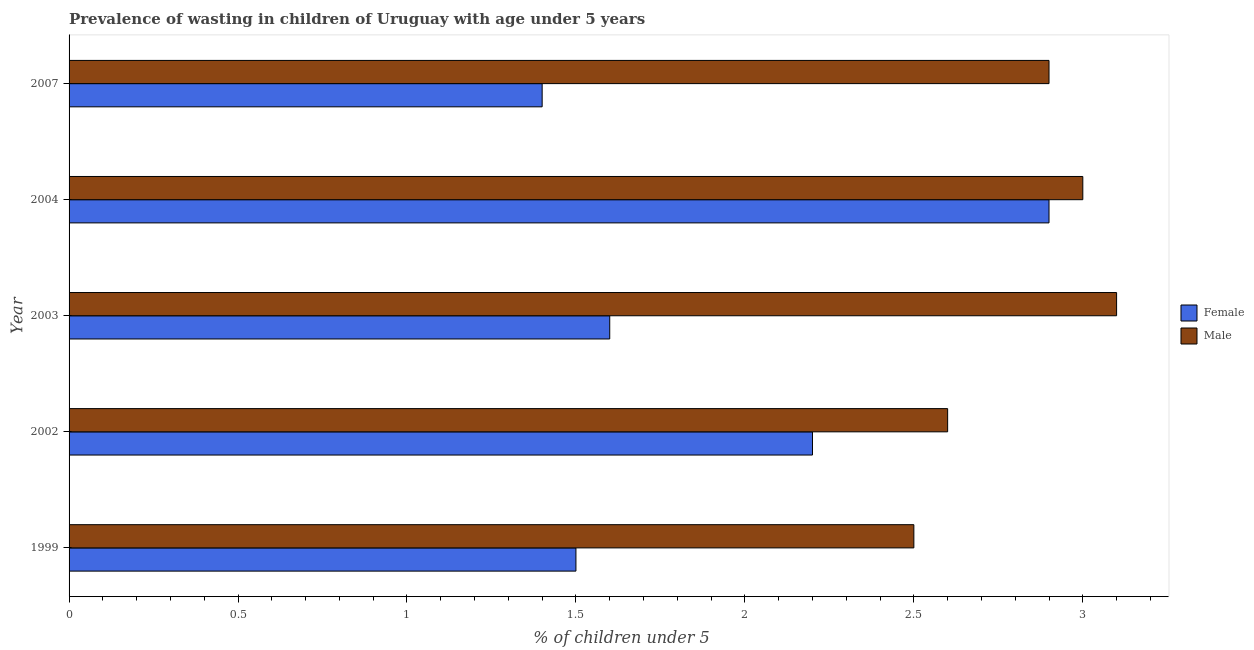How many different coloured bars are there?
Make the answer very short. 2. Are the number of bars per tick equal to the number of legend labels?
Keep it short and to the point. Yes. Are the number of bars on each tick of the Y-axis equal?
Make the answer very short. Yes. In how many cases, is the number of bars for a given year not equal to the number of legend labels?
Provide a short and direct response. 0. Across all years, what is the maximum percentage of undernourished male children?
Offer a terse response. 3.1. Across all years, what is the minimum percentage of undernourished male children?
Your response must be concise. 2.5. In which year was the percentage of undernourished male children maximum?
Provide a short and direct response. 2003. In which year was the percentage of undernourished female children minimum?
Ensure brevity in your answer.  2007. What is the total percentage of undernourished male children in the graph?
Your answer should be very brief. 14.1. What is the difference between the percentage of undernourished male children in 1999 and that in 2004?
Ensure brevity in your answer.  -0.5. What is the difference between the percentage of undernourished female children in 1999 and the percentage of undernourished male children in 2007?
Offer a very short reply. -1.4. What is the average percentage of undernourished male children per year?
Your answer should be compact. 2.82. In the year 2004, what is the difference between the percentage of undernourished female children and percentage of undernourished male children?
Offer a terse response. -0.1. In how many years, is the percentage of undernourished male children greater than 3 %?
Your response must be concise. 1. What is the ratio of the percentage of undernourished female children in 2002 to that in 2004?
Your answer should be very brief. 0.76. Is the percentage of undernourished female children in 2003 less than that in 2004?
Provide a short and direct response. Yes. Is the difference between the percentage of undernourished male children in 2003 and 2004 greater than the difference between the percentage of undernourished female children in 2003 and 2004?
Give a very brief answer. Yes. Are all the bars in the graph horizontal?
Provide a succinct answer. Yes. What is the difference between two consecutive major ticks on the X-axis?
Your answer should be very brief. 0.5. Does the graph contain grids?
Your answer should be compact. No. Where does the legend appear in the graph?
Your answer should be compact. Center right. How many legend labels are there?
Offer a terse response. 2. How are the legend labels stacked?
Your response must be concise. Vertical. What is the title of the graph?
Your answer should be compact. Prevalence of wasting in children of Uruguay with age under 5 years. What is the label or title of the X-axis?
Your answer should be compact.  % of children under 5. What is the label or title of the Y-axis?
Offer a terse response. Year. What is the  % of children under 5 of Female in 1999?
Provide a succinct answer. 1.5. What is the  % of children under 5 of Male in 1999?
Keep it short and to the point. 2.5. What is the  % of children under 5 of Female in 2002?
Your response must be concise. 2.2. What is the  % of children under 5 of Male in 2002?
Offer a very short reply. 2.6. What is the  % of children under 5 in Female in 2003?
Give a very brief answer. 1.6. What is the  % of children under 5 of Male in 2003?
Your answer should be very brief. 3.1. What is the  % of children under 5 in Female in 2004?
Provide a succinct answer. 2.9. What is the  % of children under 5 of Female in 2007?
Offer a terse response. 1.4. What is the  % of children under 5 in Male in 2007?
Provide a succinct answer. 2.9. Across all years, what is the maximum  % of children under 5 of Female?
Offer a very short reply. 2.9. Across all years, what is the maximum  % of children under 5 in Male?
Provide a short and direct response. 3.1. Across all years, what is the minimum  % of children under 5 of Female?
Offer a terse response. 1.4. Across all years, what is the minimum  % of children under 5 in Male?
Offer a very short reply. 2.5. What is the total  % of children under 5 of Female in the graph?
Keep it short and to the point. 9.6. What is the difference between the  % of children under 5 in Female in 1999 and that in 2002?
Offer a very short reply. -0.7. What is the difference between the  % of children under 5 of Female in 1999 and that in 2003?
Provide a succinct answer. -0.1. What is the difference between the  % of children under 5 of Male in 1999 and that in 2003?
Give a very brief answer. -0.6. What is the difference between the  % of children under 5 in Male in 2002 and that in 2004?
Your answer should be very brief. -0.4. What is the difference between the  % of children under 5 of Male in 2002 and that in 2007?
Your response must be concise. -0.3. What is the difference between the  % of children under 5 of Male in 2003 and that in 2004?
Keep it short and to the point. 0.1. What is the difference between the  % of children under 5 of Female in 2004 and that in 2007?
Give a very brief answer. 1.5. What is the difference between the  % of children under 5 of Female in 1999 and the  % of children under 5 of Male in 2003?
Ensure brevity in your answer.  -1.6. What is the difference between the  % of children under 5 in Female in 2002 and the  % of children under 5 in Male in 2003?
Your answer should be compact. -0.9. What is the difference between the  % of children under 5 in Female in 2003 and the  % of children under 5 in Male in 2004?
Keep it short and to the point. -1.4. What is the difference between the  % of children under 5 in Female in 2004 and the  % of children under 5 in Male in 2007?
Ensure brevity in your answer.  0. What is the average  % of children under 5 of Female per year?
Provide a short and direct response. 1.92. What is the average  % of children under 5 of Male per year?
Give a very brief answer. 2.82. In the year 2002, what is the difference between the  % of children under 5 in Female and  % of children under 5 in Male?
Give a very brief answer. -0.4. In the year 2004, what is the difference between the  % of children under 5 in Female and  % of children under 5 in Male?
Give a very brief answer. -0.1. In the year 2007, what is the difference between the  % of children under 5 of Female and  % of children under 5 of Male?
Make the answer very short. -1.5. What is the ratio of the  % of children under 5 of Female in 1999 to that in 2002?
Ensure brevity in your answer.  0.68. What is the ratio of the  % of children under 5 in Male in 1999 to that in 2002?
Offer a terse response. 0.96. What is the ratio of the  % of children under 5 of Female in 1999 to that in 2003?
Offer a terse response. 0.94. What is the ratio of the  % of children under 5 in Male in 1999 to that in 2003?
Make the answer very short. 0.81. What is the ratio of the  % of children under 5 of Female in 1999 to that in 2004?
Offer a terse response. 0.52. What is the ratio of the  % of children under 5 in Female in 1999 to that in 2007?
Provide a succinct answer. 1.07. What is the ratio of the  % of children under 5 in Male in 1999 to that in 2007?
Keep it short and to the point. 0.86. What is the ratio of the  % of children under 5 in Female in 2002 to that in 2003?
Your answer should be compact. 1.38. What is the ratio of the  % of children under 5 of Male in 2002 to that in 2003?
Your answer should be very brief. 0.84. What is the ratio of the  % of children under 5 of Female in 2002 to that in 2004?
Ensure brevity in your answer.  0.76. What is the ratio of the  % of children under 5 of Male in 2002 to that in 2004?
Ensure brevity in your answer.  0.87. What is the ratio of the  % of children under 5 in Female in 2002 to that in 2007?
Give a very brief answer. 1.57. What is the ratio of the  % of children under 5 of Male in 2002 to that in 2007?
Offer a very short reply. 0.9. What is the ratio of the  % of children under 5 of Female in 2003 to that in 2004?
Provide a short and direct response. 0.55. What is the ratio of the  % of children under 5 in Male in 2003 to that in 2007?
Provide a short and direct response. 1.07. What is the ratio of the  % of children under 5 of Female in 2004 to that in 2007?
Offer a terse response. 2.07. What is the ratio of the  % of children under 5 in Male in 2004 to that in 2007?
Provide a succinct answer. 1.03. What is the difference between the highest and the second highest  % of children under 5 of Female?
Provide a short and direct response. 0.7. What is the difference between the highest and the second highest  % of children under 5 of Male?
Keep it short and to the point. 0.1. What is the difference between the highest and the lowest  % of children under 5 in Male?
Provide a short and direct response. 0.6. 